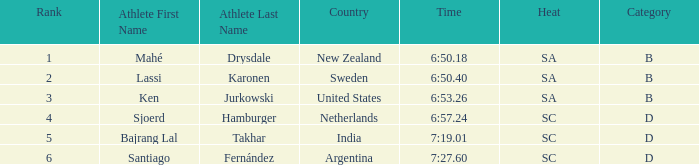What is the sum of the ranks for india? 5.0. 